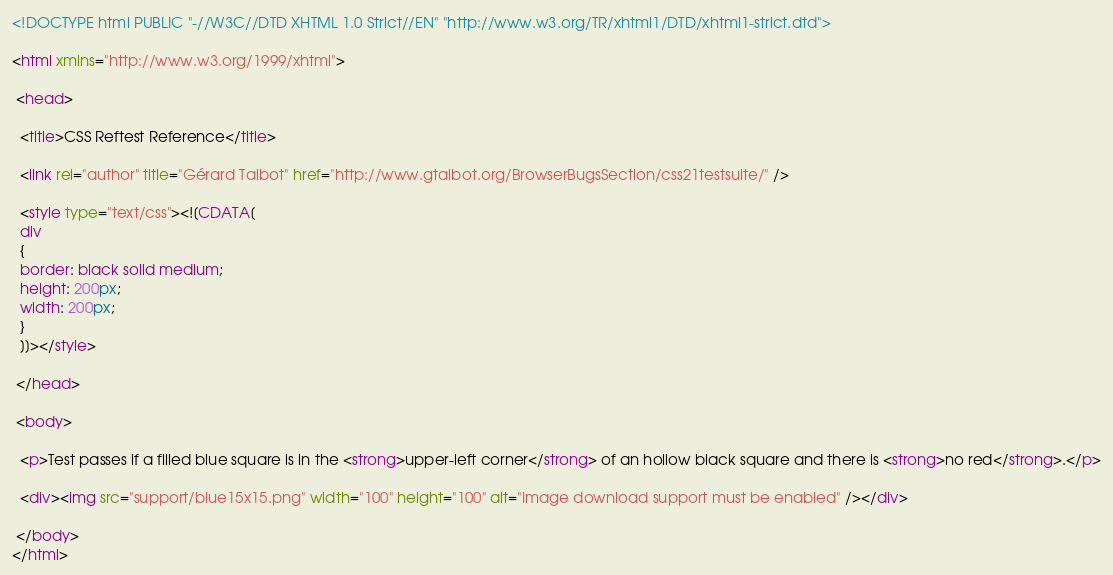<code> <loc_0><loc_0><loc_500><loc_500><_HTML_><!DOCTYPE html PUBLIC "-//W3C//DTD XHTML 1.0 Strict//EN" "http://www.w3.org/TR/xhtml1/DTD/xhtml1-strict.dtd">

<html xmlns="http://www.w3.org/1999/xhtml">

 <head>

  <title>CSS Reftest Reference</title>

  <link rel="author" title="Gérard Talbot" href="http://www.gtalbot.org/BrowserBugsSection/css21testsuite/" />
  
  <style type="text/css"><![CDATA[
  div
  {
  border: black solid medium;
  height: 200px;
  width: 200px;
  }
  ]]></style>

 </head>

 <body>

  <p>Test passes if a filled blue square is in the <strong>upper-left corner</strong> of an hollow black square and there is <strong>no red</strong>.</p>

  <div><img src="support/blue15x15.png" width="100" height="100" alt="Image download support must be enabled" /></div>

 </body>
</html></code> 